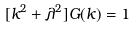<formula> <loc_0><loc_0><loc_500><loc_500>[ k ^ { 2 } + \lambda ^ { 2 } ] G ( k ) = 1</formula> 